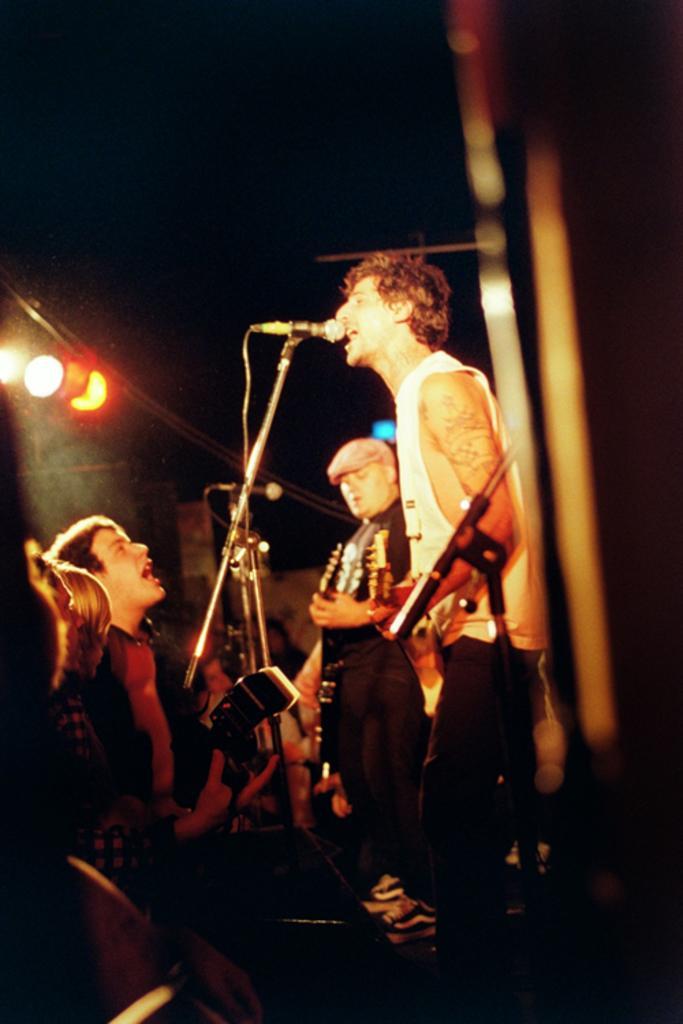Describe this image in one or two sentences. In this picture we can see man standing holding guitar in his hand and playing and singing on a mic and we can see group of people listening to his music and in the background we can see light. 